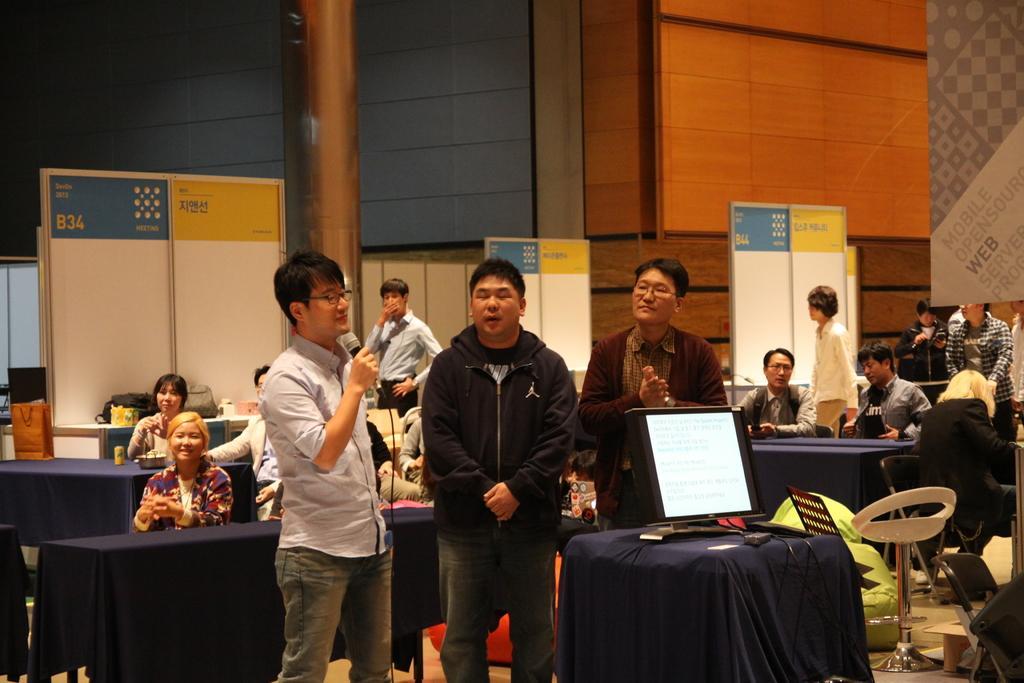Can you describe this image briefly? In the middle of this image, there are three persons in different color dresses, standing. One of them is holding a mic. Beside them, there is a screen arranged on a table which is covered with a cloth. In the background, there are other persons, tables arranged, white color boards arranged, a pillar and a wall. 